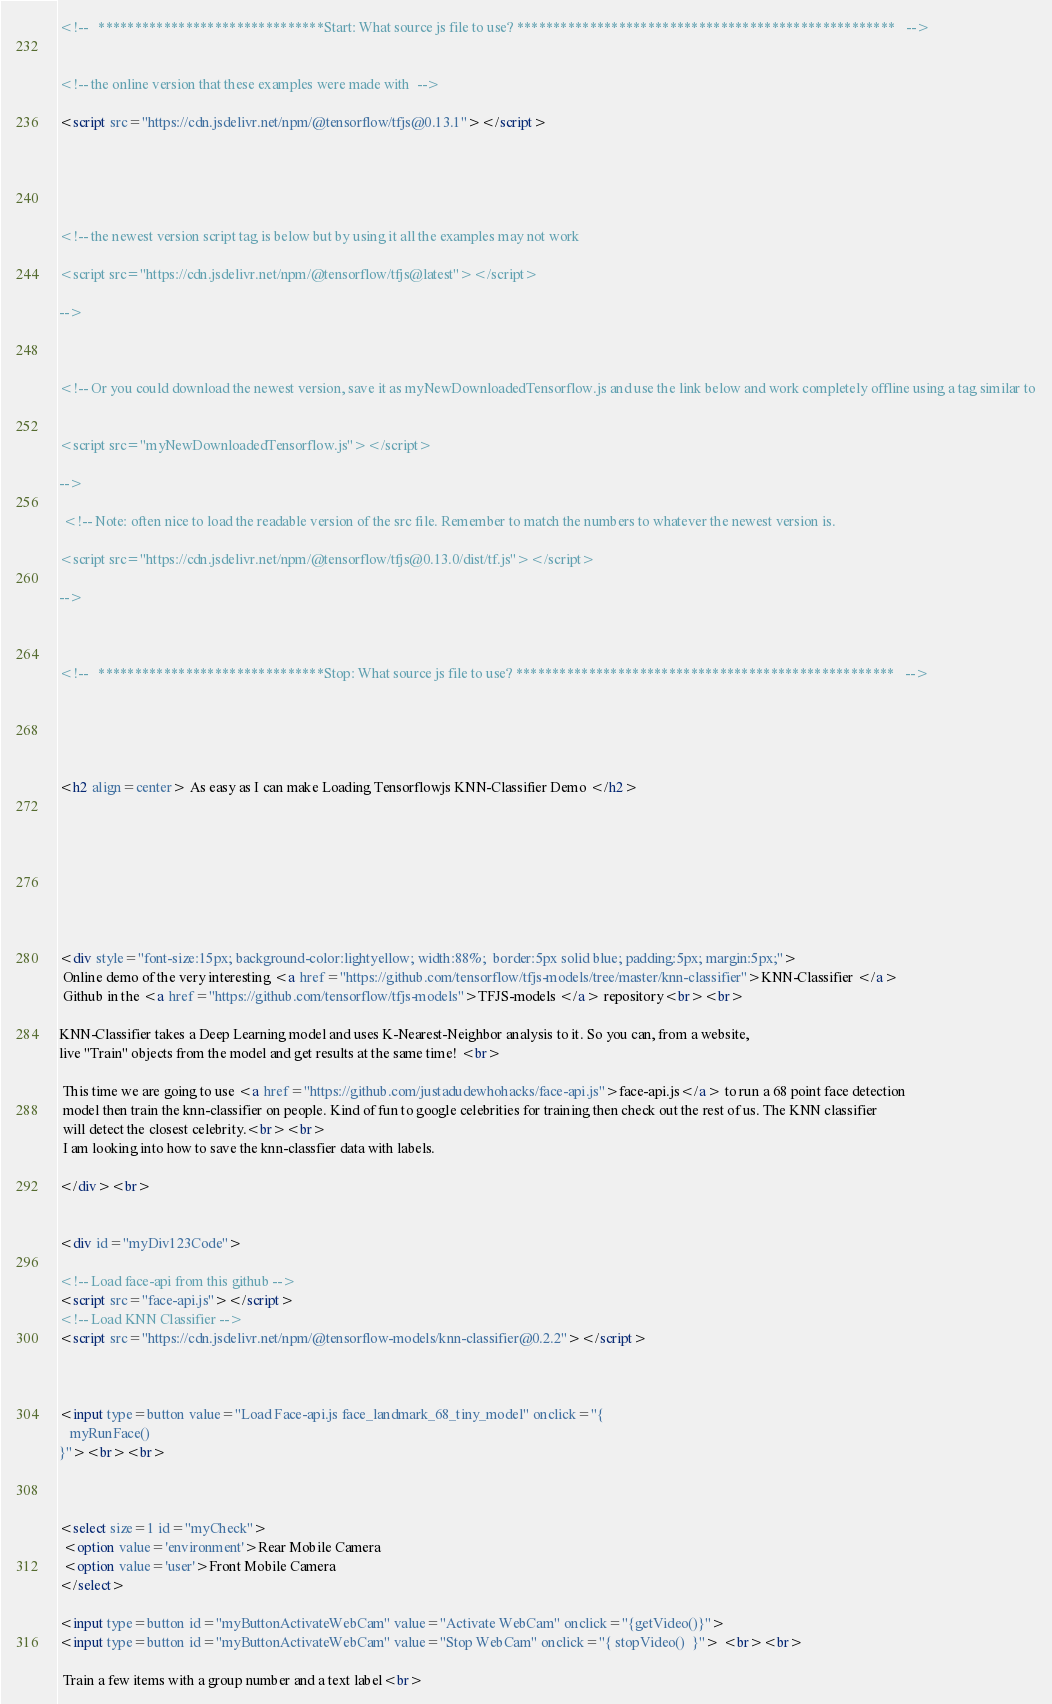<code> <loc_0><loc_0><loc_500><loc_500><_HTML_>
<!--   *******************************Start: What source js file to use? ****************************************************   -->


<!-- the online version that these examples were made with  -->

<script src="https://cdn.jsdelivr.net/npm/@tensorflow/tfjs@0.13.1"></script>





<!-- the newest version script tag is below but by using it all the examples may not work 

<script src="https://cdn.jsdelivr.net/npm/@tensorflow/tfjs@latest"></script>

-->



<!-- Or you could download the newest version, save it as myNewDownloadedTensorflow.js and use the link below and work completely offline using a tag similar to


<script src="myNewDownloadedTensorflow.js"></script>

-->

 <!-- Note: often nice to load the readable version of the src file. Remember to match the numbers to whatever the newest version is.

<script src="https://cdn.jsdelivr.net/npm/@tensorflow/tfjs@0.13.0/dist/tf.js"></script>

--> 



<!--   *******************************Stop: What source js file to use? ****************************************************   -->



    
    
<h2 align=center> As easy as I can make Loading Tensorflowjs KNN-Classifier Demo </h2>








<div style="font-size:15px; background-color:lightyellow; width:88%;  border:5px solid blue; padding:5px; margin:5px;"> 
 Online demo of the very interesting <a href="https://github.com/tensorflow/tfjs-models/tree/master/knn-classifier">KNN-Classifier </a> 
 Github in the <a href="https://github.com/tensorflow/tfjs-models">TFJS-models </a> repository<br><br>
 
KNN-Classifier takes a Deep Learning model and uses K-Nearest-Neighbor analysis to it. So you can, from a website, 
live "Train" objects from the model and get results at the same time! <br>
 
 This time we are going to use <a href="https://github.com/justadudewhohacks/face-api.js">face-api.js</a> to run a 68 point face detection
 model then train the knn-classifier on people. Kind of fun to google celebrities for training then check out the rest of us. The KNN classifier
 will detect the closest celebrity.<br><br>
 I am looking into how to save the knn-classfier data with labels.
 
</div><br>


<div id="myDiv123Code"> 

<!-- Load face-api from this github -->
<script src="face-api.js"></script>
<!-- Load KNN Classifier -->
<script src="https://cdn.jsdelivr.net/npm/@tensorflow-models/knn-classifier@0.2.2"></script> 
    


<input type=button value="Load Face-api.js face_landmark_68_tiny_model" onclick="{
   myRunFace() 
}"><br><br>



<select size=1 id="myCheck">
 <option value='environment'>Rear Mobile Camera
 <option value='user'>Front Mobile Camera
</select>

<input type=button id="myButtonActivateWebCam" value="Activate WebCam" onclick="{getVideo()}"> 
<input type=button id="myButtonActivateWebCam" value="Stop WebCam" onclick="{ stopVideo()  }"> <br><br>
 
 Train a few items with a group number and a text label<br></code> 